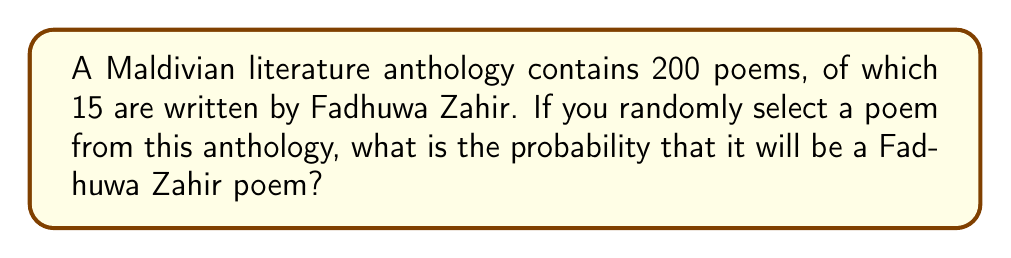Solve this math problem. To solve this problem, we need to use the concept of probability. The probability of an event is calculated by dividing the number of favorable outcomes by the total number of possible outcomes.

1. Total number of poems in the anthology: 200
2. Number of Fadhuwa Zahir's poems: 15

Let's define the event A as "selecting a Fadhuwa Zahir poem."

The probability of event A, P(A), is:

$$P(A) = \frac{\text{Number of favorable outcomes}}{\text{Total number of possible outcomes}}$$

Substituting the values:

$$P(A) = \frac{15}{200}$$

To simplify this fraction:

$$P(A) = \frac{15}{200} = \frac{3}{40} = 0.075$$

Therefore, the probability of randomly selecting a Fadhuwa Zahir poem from this Maldivian literature anthology is 0.075 or 7.5%.
Answer: $\frac{3}{40}$ or 0.075 or 7.5% 